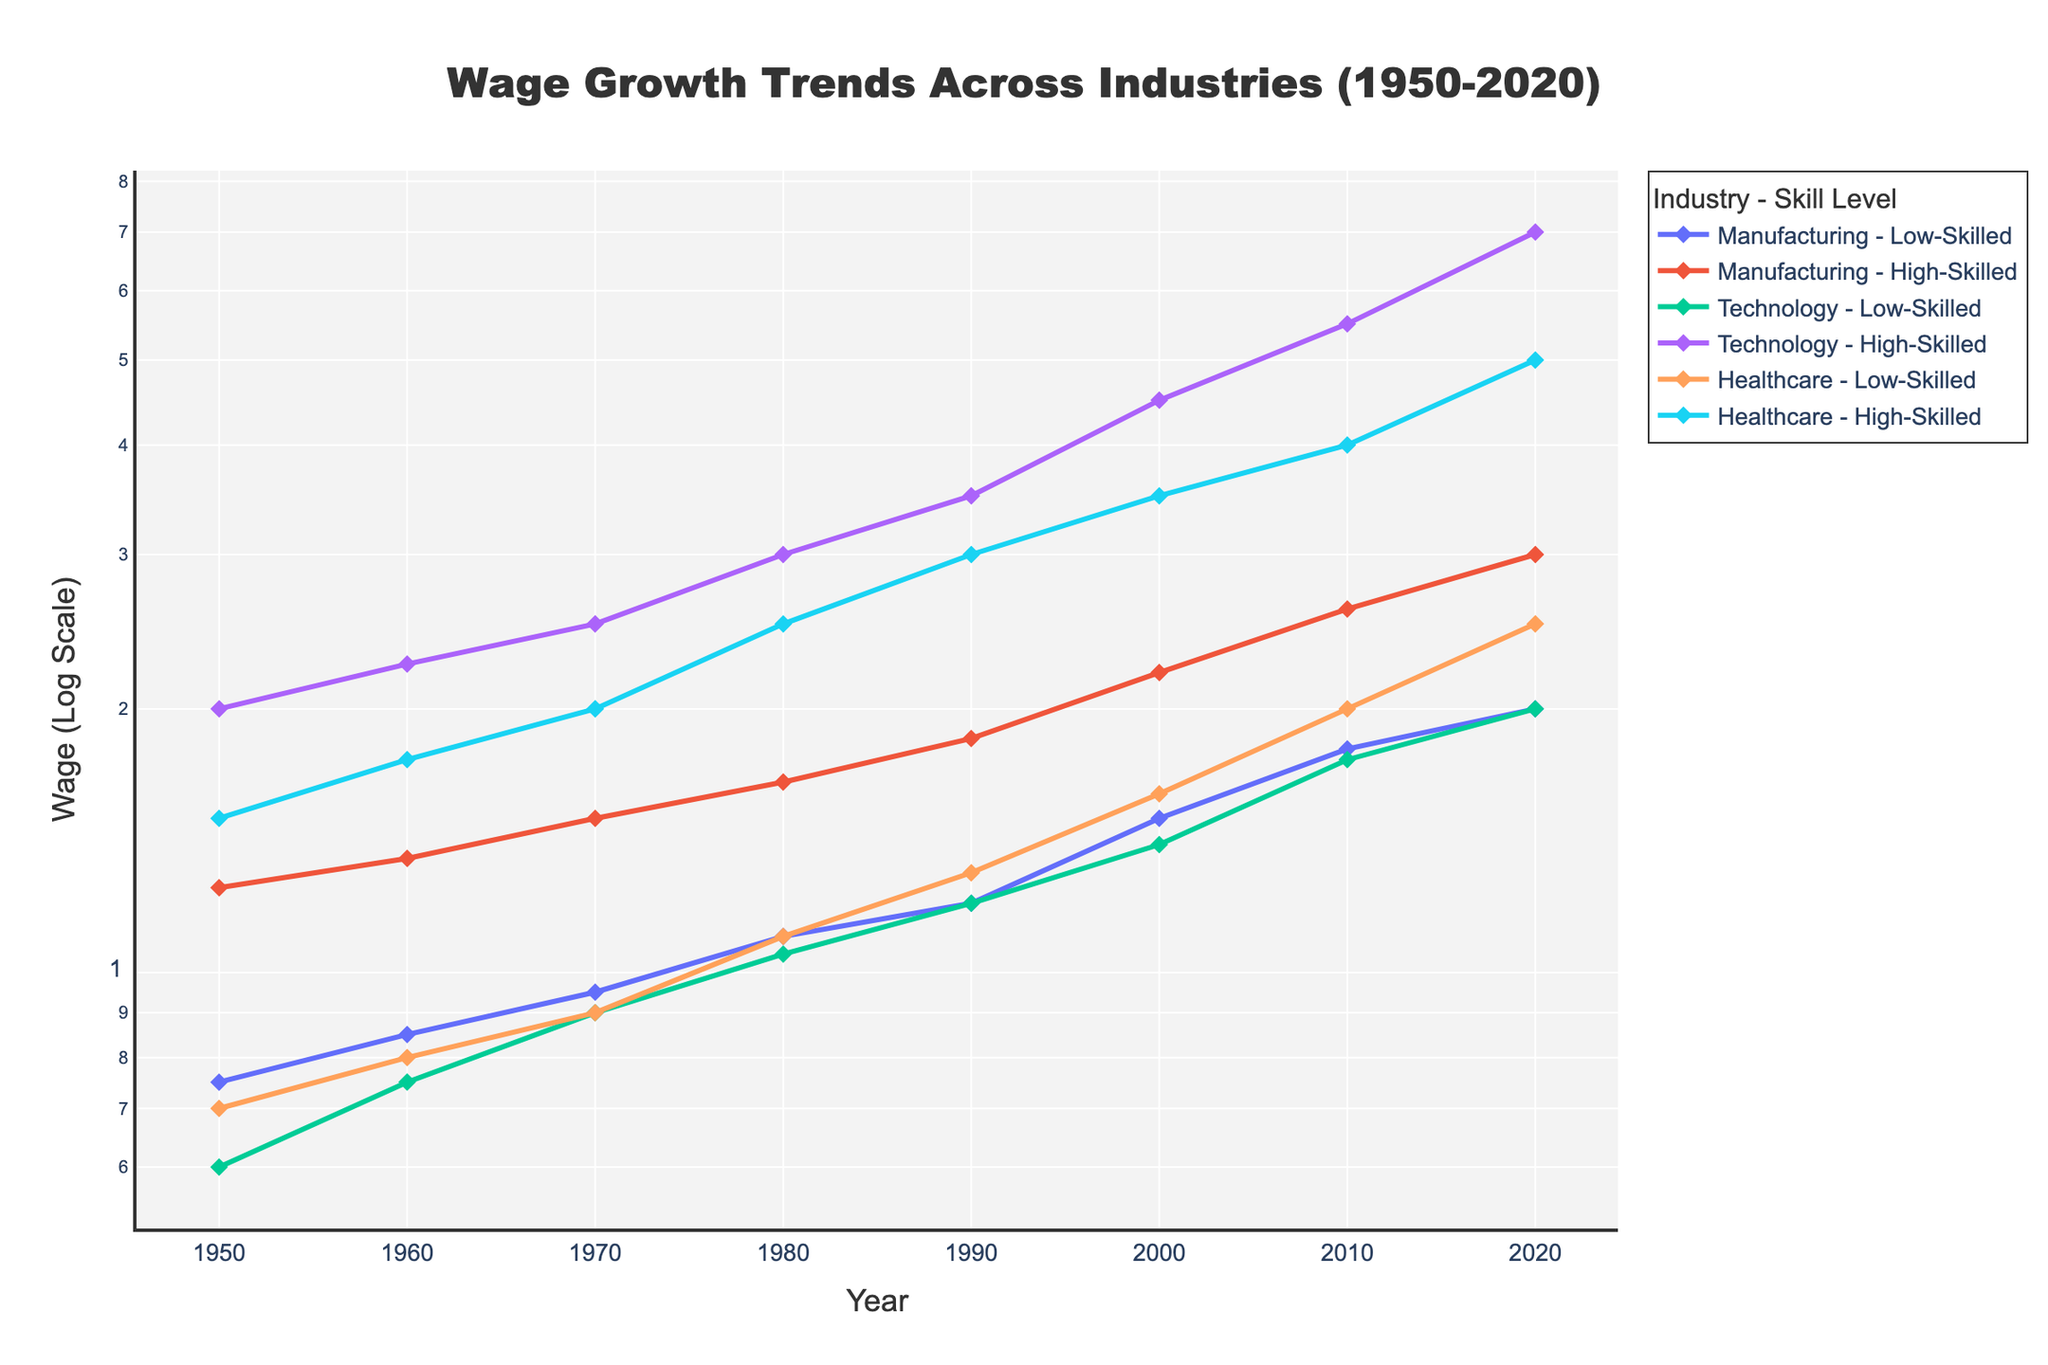Which industry and skill level group had the highest wage in 2020? By looking at the end of the plot lines for 2020, the "Technology - High-Skilled" group has the highest wage among all the groups.
Answer: Technology - High-Skilled What is the general trend of wage growth for low-skilled workers in the manufacturing industry from 1950 to 2020? Observing the line corresponding to "Manufacturing - Low-Skilled," wages show a steady increase from 1950 to 2020.
Answer: Steady increase How do the wages of high-skilled workers in Healthcare compare between 1950 and 1990? By comparing the plot points for "Healthcare - High-Skilled" in 1950 and 1990, wages increase from 1.50 to 3.00.
Answer: Increased from 1.50 to 3.00 Which industry-skill combination had the smallest wage growth from 1950 to 2020? By analyzing the slope of the lines, "Manufacturing - High-Skilled" shows the smallest relative growth, compared to "Technology - High-Skilled" which grew the most.
Answer: Manufacturing - High-Skilled What is the approximate wage difference between low-skilled and high-skilled workers in the technology industry in 2020? Subtracting the wage of low-skilled workers from high-skilled workers in the technology sector for 2020, 7.00 - 2.00, the difference is 5.00.
Answer: 5.00 How did the wages in the healthcare industry for low-skilled workers change from 1980 to 2000? Identifying the points for "Healthcare - Low-Skilled" in 1980 and 2000, wages grew from 1.10 to 1.60.
Answer: Increased from 1.10 to 1.60 Which skill level group in manufacturing had a greater rate of wage increase from 1950 to 2020? By analyzing the gradient of the lines, "Manufacturing - Low-Skilled" shows a smaller rate of increase when compared directly to "Manufacturing - High-Skilled."
Answer: High-Skilled Are the wage growth trends for low-skilled and high-skilled workers more similar in the healthcare or manufacturing industries? Looking at the overlap and spacing of the lines, healthcare's low- and high-skilled trends are more similar compared to manufacturing.
Answer: Healthcare Did any industry see a decline in wages for any skill level between any of the decades listed? Exploring the plot lines, no observable declines in wages for any skill level in any industry between the given decades.
Answer: No In which decade did the wages for low-skilled workers in the technology industry first surpass 1.00? Observing the "Technology - Low-Skilled" line, the wage surpasses 1.00 between 1970 and 1980.
Answer: 1980 